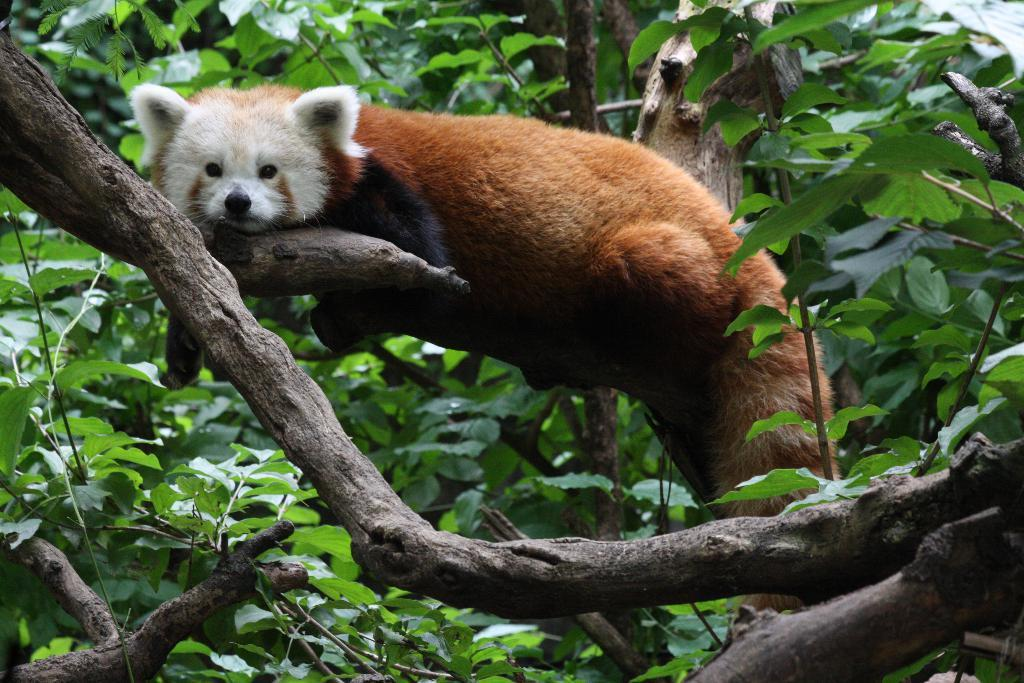What type of animal can be seen in the image? There is an animal in the image, but its specific type cannot be determined from the provided facts. Where is the animal located in the image? The animal is on a branch of a tree in the image. What can be seen in the background of the image? There are trees visible in the background of the image. How many fingers does the beggar have in the image? There is no beggar present in the image, so it is not possible to determine the number of fingers they might have. 